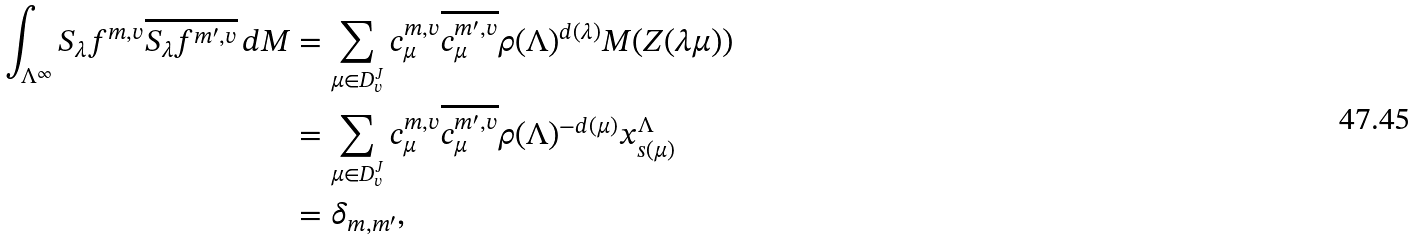<formula> <loc_0><loc_0><loc_500><loc_500>\int _ { \Lambda ^ { \infty } } S _ { \lambda } f ^ { m , v } \overline { S _ { \lambda } f ^ { m ^ { \prime } , v } } \, d M & = \sum _ { \mu \in D _ { v } ^ { J } } c ^ { m , v } _ { \mu } \overline { c ^ { m ^ { \prime } , v } _ { \mu } } \rho ( \Lambda ) ^ { d ( \lambda ) } M ( Z ( \lambda \mu ) ) \\ & = \sum _ { \mu \in D _ { v } ^ { J } } c ^ { m , v } _ { \mu } \overline { c ^ { m ^ { \prime } , v } _ { \mu } } \rho ( \Lambda ) ^ { - d ( \mu ) } x ^ { \Lambda } _ { s ( \mu ) } \\ & = \delta _ { m , m ^ { \prime } } ,</formula> 